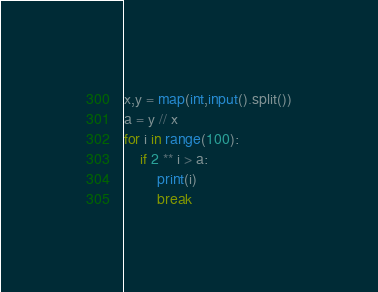Convert code to text. <code><loc_0><loc_0><loc_500><loc_500><_Python_>x,y = map(int,input().split())
a = y // x
for i in range(100):
    if 2 ** i > a:
        print(i)
        break</code> 